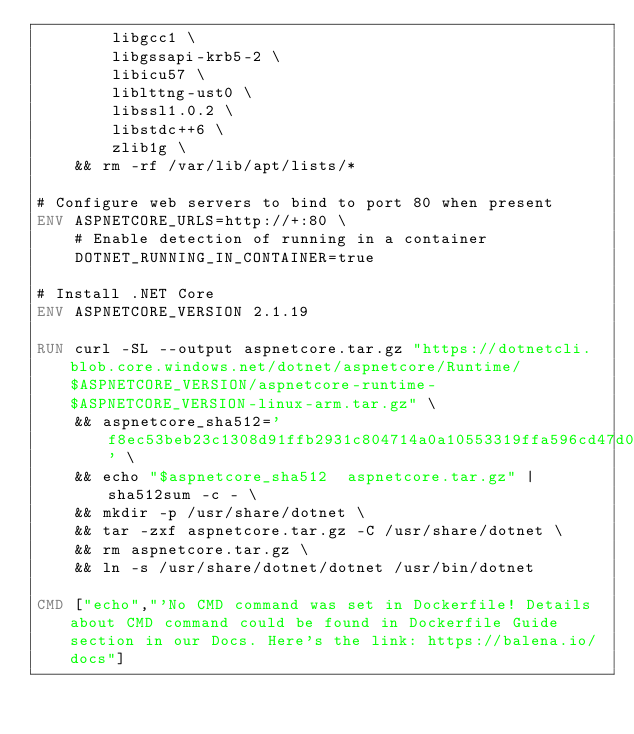Convert code to text. <code><loc_0><loc_0><loc_500><loc_500><_Dockerfile_>        libgcc1 \
        libgssapi-krb5-2 \
        libicu57 \
        liblttng-ust0 \
        libssl1.0.2 \
        libstdc++6 \
        zlib1g \
    && rm -rf /var/lib/apt/lists/*

# Configure web servers to bind to port 80 when present
ENV ASPNETCORE_URLS=http://+:80 \
    # Enable detection of running in a container
    DOTNET_RUNNING_IN_CONTAINER=true

# Install .NET Core
ENV ASPNETCORE_VERSION 2.1.19

RUN curl -SL --output aspnetcore.tar.gz "https://dotnetcli.blob.core.windows.net/dotnet/aspnetcore/Runtime/$ASPNETCORE_VERSION/aspnetcore-runtime-$ASPNETCORE_VERSION-linux-arm.tar.gz" \
    && aspnetcore_sha512='f8ec53beb23c1308d91ffb2931c804714a0a10553319ffa596cd47d00cf324207130397f90ab5b78dc3d4f408eefd6753221254abaf0d02ffca9522b85851892' \
    && echo "$aspnetcore_sha512  aspnetcore.tar.gz" | sha512sum -c - \
    && mkdir -p /usr/share/dotnet \
    && tar -zxf aspnetcore.tar.gz -C /usr/share/dotnet \
    && rm aspnetcore.tar.gz \
    && ln -s /usr/share/dotnet/dotnet /usr/bin/dotnet

CMD ["echo","'No CMD command was set in Dockerfile! Details about CMD command could be found in Dockerfile Guide section in our Docs. Here's the link: https://balena.io/docs"]
</code> 